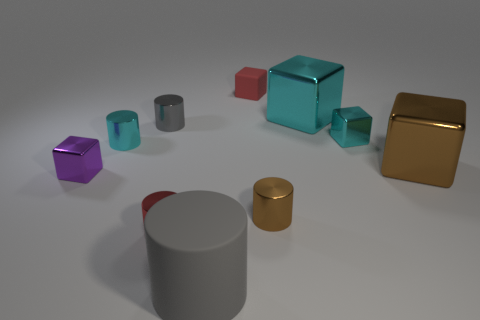What number of metallic things have the same color as the big cylinder?
Offer a terse response. 1. Do the brown cylinder and the red thing in front of the small red block have the same size?
Give a very brief answer. Yes. What is the small cylinder that is right of the tiny red matte object made of?
Offer a terse response. Metal. Are there an equal number of big metallic objects that are on the right side of the tiny red metal thing and large shiny blocks?
Provide a succinct answer. Yes. Do the brown shiny block and the gray rubber thing have the same size?
Give a very brief answer. Yes. Is there a cyan metal thing right of the gray cylinder behind the tiny metal block left of the brown metal cylinder?
Provide a short and direct response. Yes. There is a tiny brown thing that is the same shape as the large gray matte object; what material is it?
Your answer should be compact. Metal. What number of cubes are in front of the small red object that is behind the big cyan object?
Make the answer very short. 4. How big is the rubber thing that is in front of the brown block that is in front of the large cube on the left side of the large brown metal object?
Ensure brevity in your answer.  Large. What is the color of the tiny cylinder to the left of the small shiny object behind the tiny cyan metal block?
Provide a succinct answer. Cyan. 